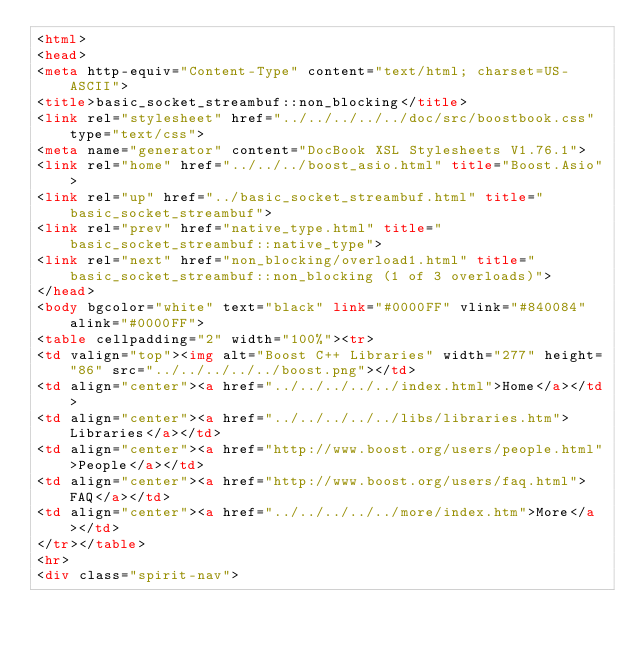Convert code to text. <code><loc_0><loc_0><loc_500><loc_500><_HTML_><html>
<head>
<meta http-equiv="Content-Type" content="text/html; charset=US-ASCII">
<title>basic_socket_streambuf::non_blocking</title>
<link rel="stylesheet" href="../../../../../doc/src/boostbook.css" type="text/css">
<meta name="generator" content="DocBook XSL Stylesheets V1.76.1">
<link rel="home" href="../../../boost_asio.html" title="Boost.Asio">
<link rel="up" href="../basic_socket_streambuf.html" title="basic_socket_streambuf">
<link rel="prev" href="native_type.html" title="basic_socket_streambuf::native_type">
<link rel="next" href="non_blocking/overload1.html" title="basic_socket_streambuf::non_blocking (1 of 3 overloads)">
</head>
<body bgcolor="white" text="black" link="#0000FF" vlink="#840084" alink="#0000FF">
<table cellpadding="2" width="100%"><tr>
<td valign="top"><img alt="Boost C++ Libraries" width="277" height="86" src="../../../../../boost.png"></td>
<td align="center"><a href="../../../../../index.html">Home</a></td>
<td align="center"><a href="../../../../../libs/libraries.htm">Libraries</a></td>
<td align="center"><a href="http://www.boost.org/users/people.html">People</a></td>
<td align="center"><a href="http://www.boost.org/users/faq.html">FAQ</a></td>
<td align="center"><a href="../../../../../more/index.htm">More</a></td>
</tr></table>
<hr>
<div class="spirit-nav"></code> 